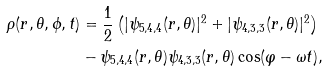Convert formula to latex. <formula><loc_0><loc_0><loc_500><loc_500>\rho ( r , \theta , \phi , t ) & = \frac { 1 } { 2 } \left ( | \psi _ { 5 , 4 , 4 } ( r , \theta ) | ^ { 2 } + | \psi _ { 4 , 3 , 3 } ( r , \theta ) | ^ { 2 } \right ) \\ & - \psi _ { 5 , 4 , 4 } ( r , \theta ) \psi _ { 4 , 3 , 3 } ( r , \theta ) \cos ( \varphi - \omega t ) ,</formula> 